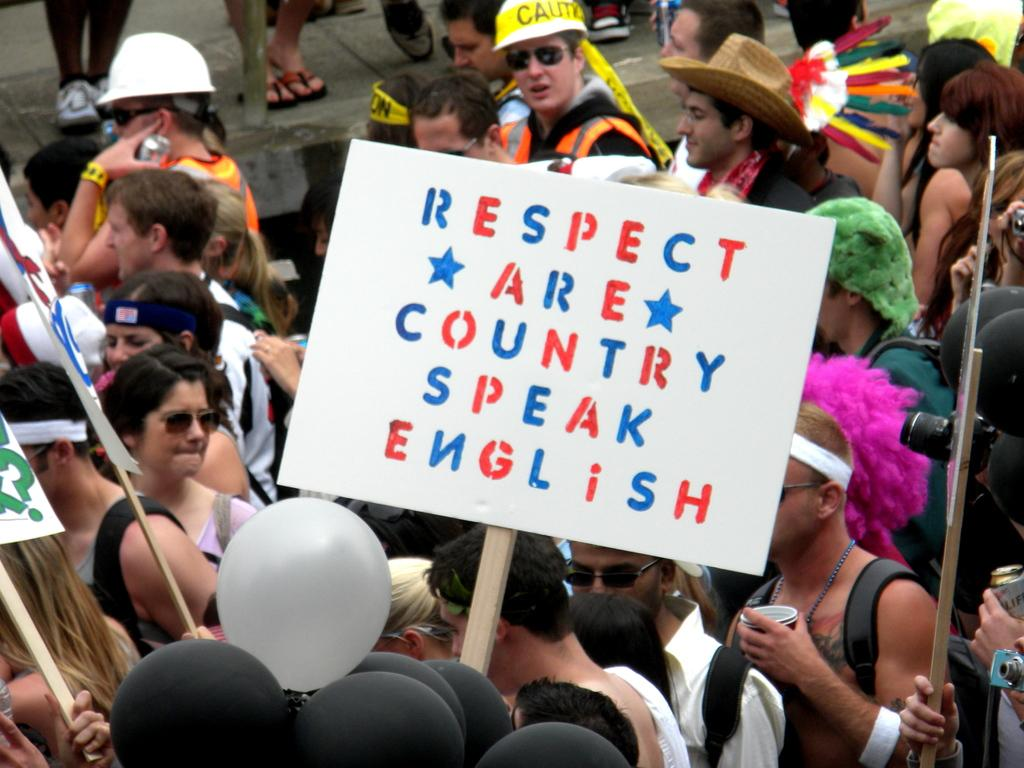How many people are in the image? There is a group of people in the image. What is one person holding in the image? One person is holding a white board. What can be seen in the background of the image? There are multi-colored objects in the background of the image. What is the name of the daughter of the person holding the white board? There is no mention of a daughter or any personal information about the people in the image, so we cannot answer that question. 